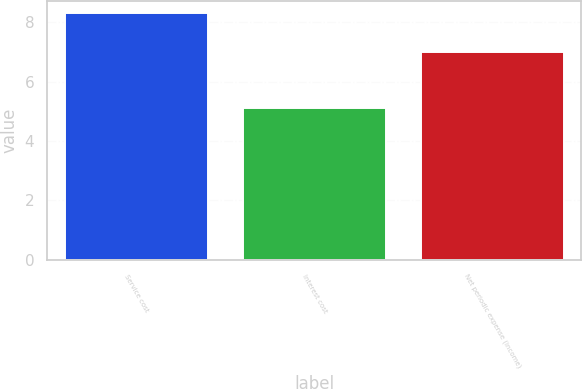<chart> <loc_0><loc_0><loc_500><loc_500><bar_chart><fcel>Service cost<fcel>Interest cost<fcel>Net periodic expense (income)<nl><fcel>8.3<fcel>5.1<fcel>7<nl></chart> 